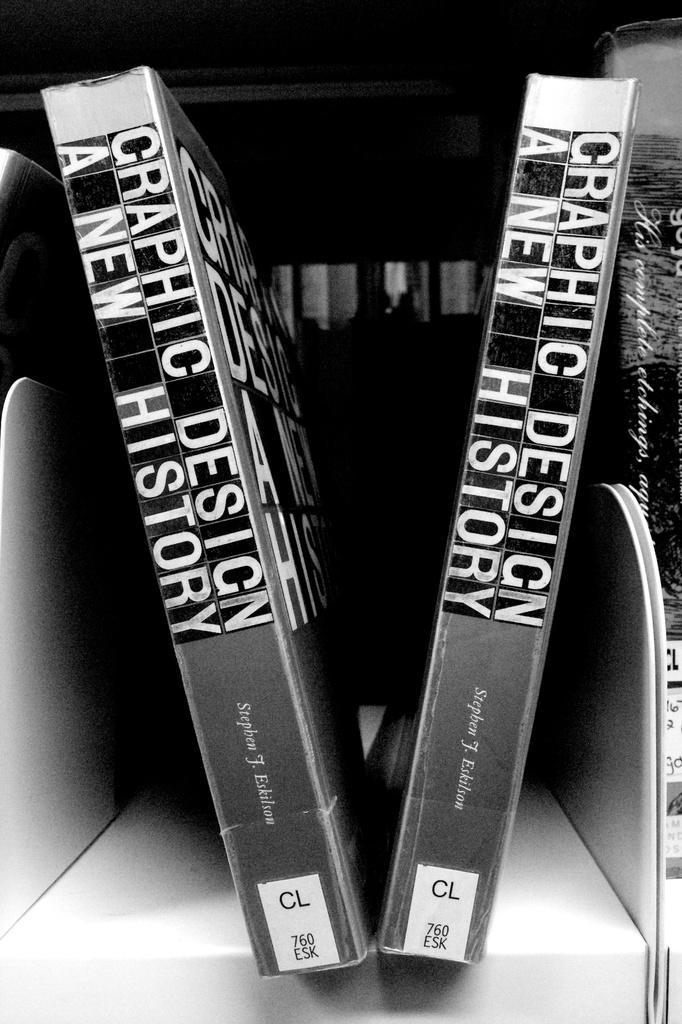Could you give a brief overview of what you see in this image? This is black and white image where we can see three books on the shelf. 